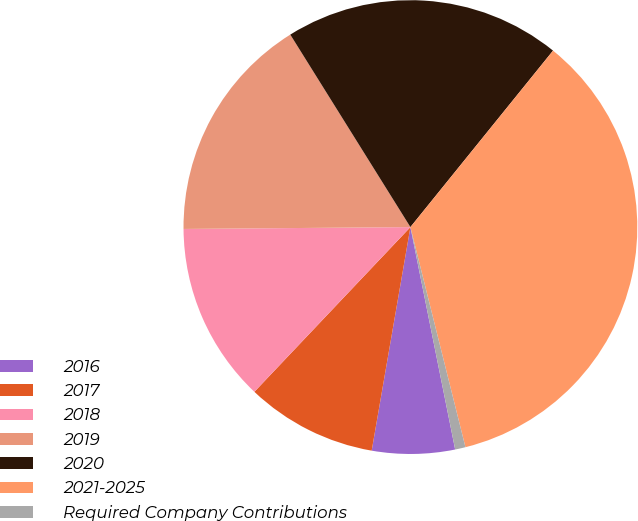<chart> <loc_0><loc_0><loc_500><loc_500><pie_chart><fcel>2016<fcel>2017<fcel>2018<fcel>2019<fcel>2020<fcel>2021-2025<fcel>Required Company Contributions<nl><fcel>5.89%<fcel>9.34%<fcel>12.8%<fcel>16.25%<fcel>19.7%<fcel>35.28%<fcel>0.74%<nl></chart> 